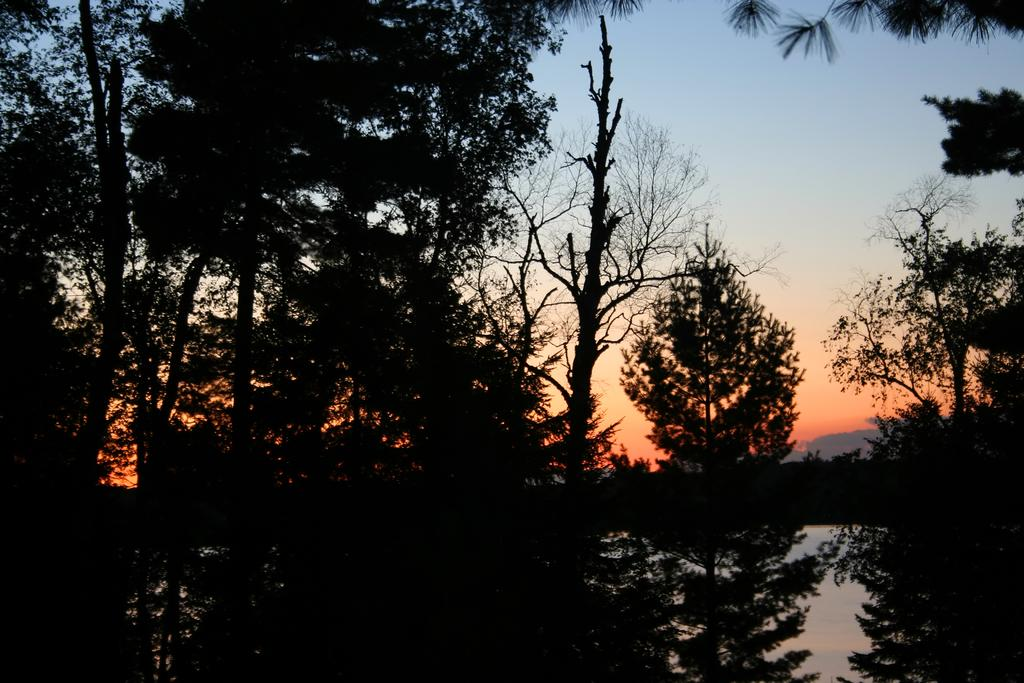What type of vegetation can be seen in the image? There are trees in the image. What part of the natural environment is visible in the image? The sky is visible in the background of the image. Where is the clock located in the image? There is no clock present in the image. What type of lock can be seen securing the jail in the image? There is no jail or lock present in the image. 